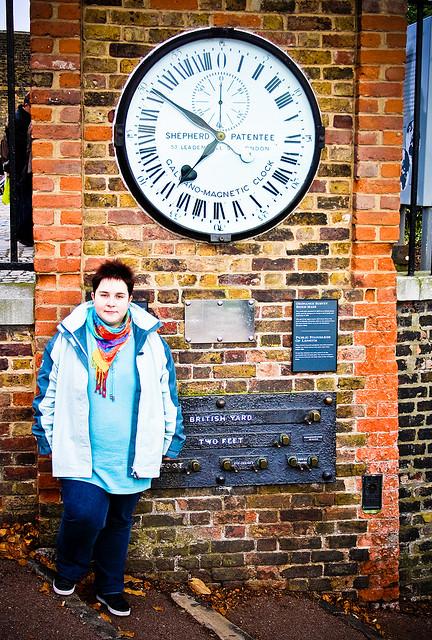What is the main color this person is wearing?
Keep it brief. Blue. What is the person in this picture doing?
Quick response, please. Standing. What makes this clock different from most other clocks?
Quick response, please. Roman numbers. 